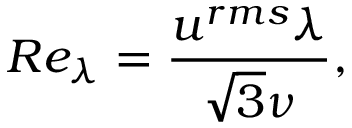<formula> <loc_0><loc_0><loc_500><loc_500>R e _ { \lambda } = \frac { u ^ { r m s } \lambda } { \sqrt { 3 } \nu } ,</formula> 